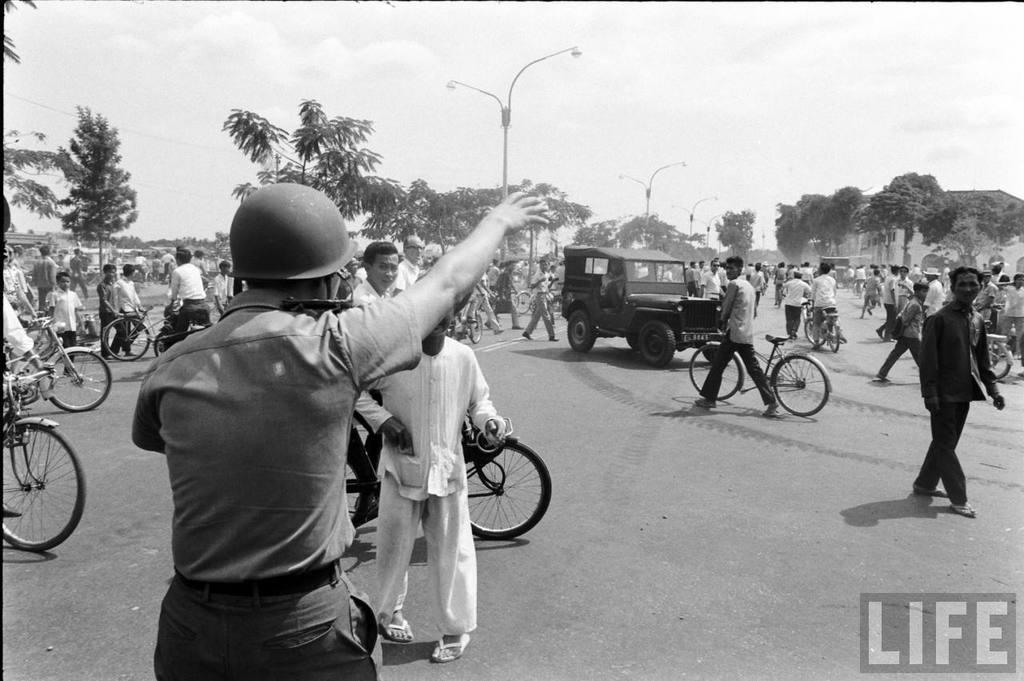What is the color scheme of the image? The image is black and white. What are the people in the image doing? The people in the image are riding bicycles on the road. What else can be seen on the road besides bicycles? There are vehicles on the road. What type of lighting is present in the image? There are street lights in the image. What is visible at the top of the image? The sky is visible at the top of the image. What type of grip can be seen on the wrench used by the person riding the bicycle in the image? There is no wrench present in the image, and the people riding bicycles do not have any tools with them. How does the coastline appear in the image? There is no coastline visible in the image; it features a road with people riding bicycles and vehicles. 